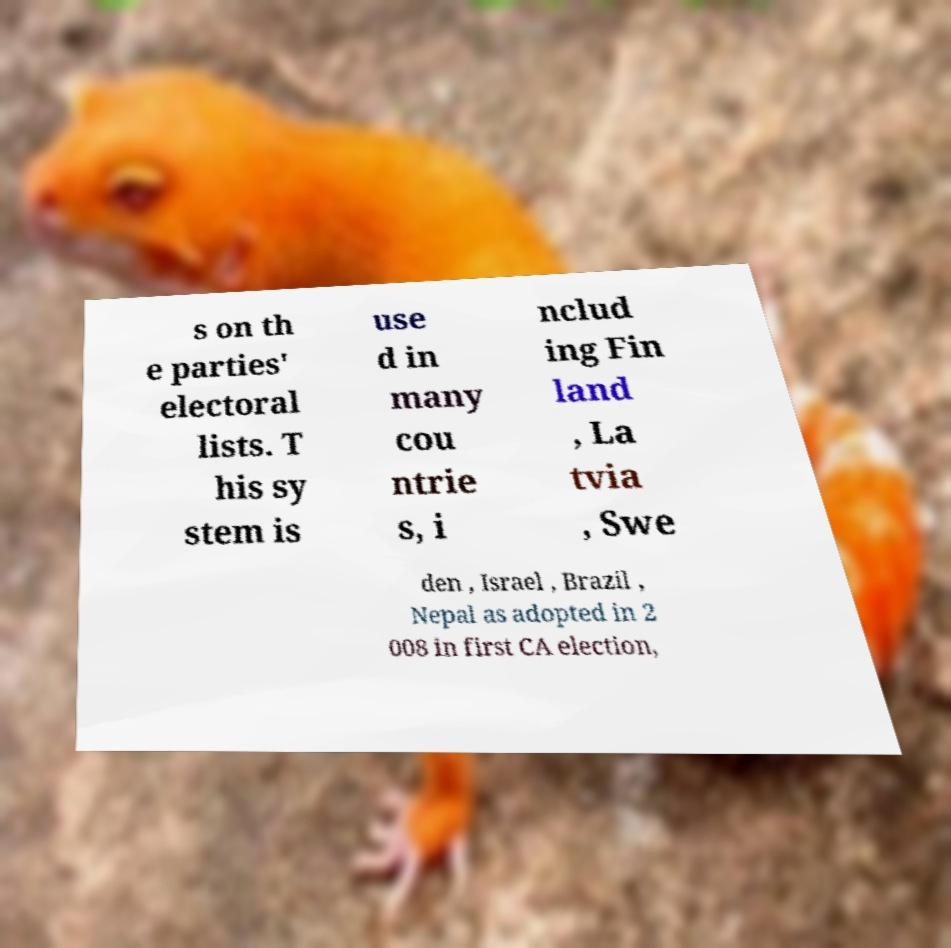Please read and relay the text visible in this image. What does it say? s on th e parties' electoral lists. T his sy stem is use d in many cou ntrie s, i nclud ing Fin land , La tvia , Swe den , Israel , Brazil , Nepal as adopted in 2 008 in first CA election, 